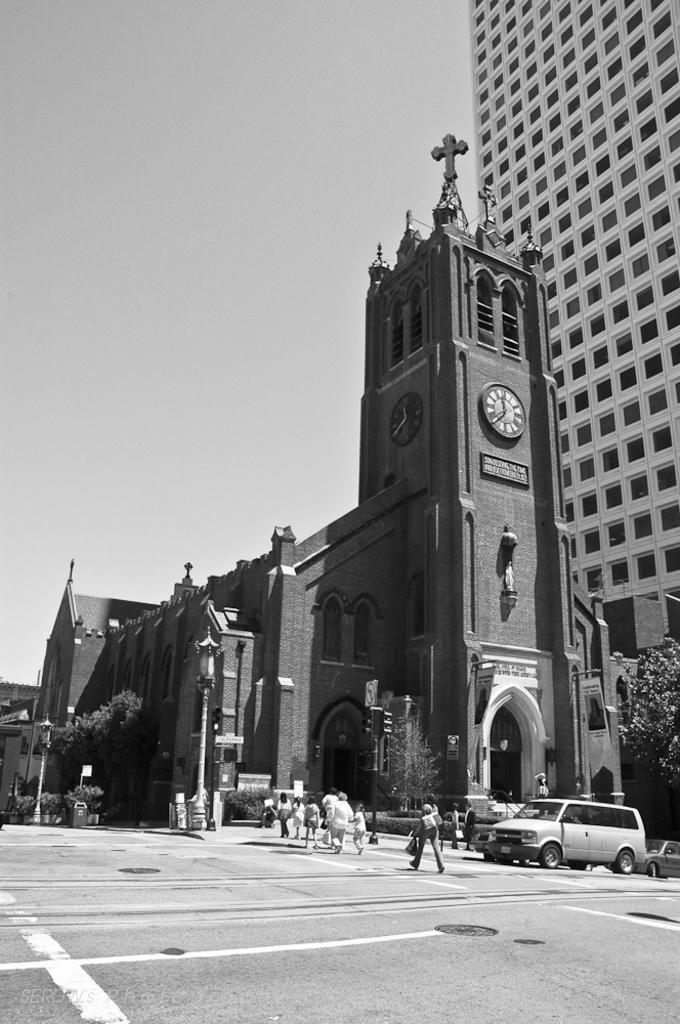Please provide a concise description of this image. In this image we can see a black and white picture of a building containing a clock on it. To the right side of the image we can see a car parked on the road. In the center of the image we can see a group of people standing on road, light pole. In the background, we can see a building, tree and the sky. 